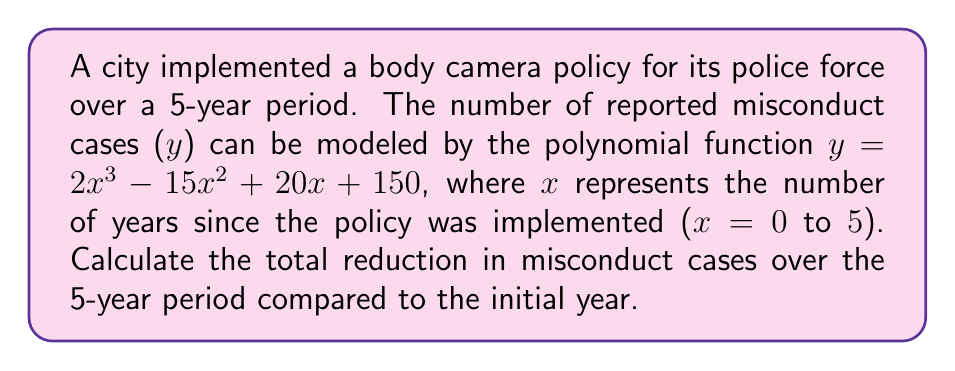Show me your answer to this math problem. To solve this problem, we need to follow these steps:

1) First, let's calculate the number of misconduct cases at the beginning (x = 0) and end (x = 5) of the 5-year period.

   For x = 0:
   $y = 2(0)^3 - 15(0)^2 + 20(0) + 150 = 150$ cases

   For x = 5:
   $y = 2(5)^3 - 15(5)^2 + 20(5) + 150$
   $= 250 - 375 + 100 + 150 = 125$ cases

2) Now, we can calculate the reduction in cases:
   $150 - 125 = 25$ cases

3) However, this only gives us the difference between the start and end points. To find the total reduction over the entire period, we need to calculate the area between the initial number of cases (150) and the curve over the 5-year period.

4) To do this, we need to integrate the difference between 150 and our function from 0 to 5:

   $\int_0^5 (150 - (2x^3 - 15x^2 + 20x + 150)) dx$

   $= \int_0^5 (-2x^3 + 15x^2 - 20x) dx$

5) Integrating this polynomial:

   $[-\frac{1}{2}x^4 + 5x^3 - 10x^2]_0^5$

6) Evaluating at the limits:

   $(-\frac{1}{2}(5)^4 + 5(5)^3 - 10(5)^2) - (-\frac{1}{2}(0)^4 + 5(0)^3 - 10(0)^2)$

   $= (-312.5 + 625 - 250) - 0 = 62.5$

Therefore, the total reduction in misconduct cases over the 5-year period is 62.5 cases.
Answer: 62.5 cases 